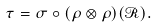Convert formula to latex. <formula><loc_0><loc_0><loc_500><loc_500>\tau = \sigma \circ ( \rho \otimes \rho ) ( \mathcal { R } ) .</formula> 